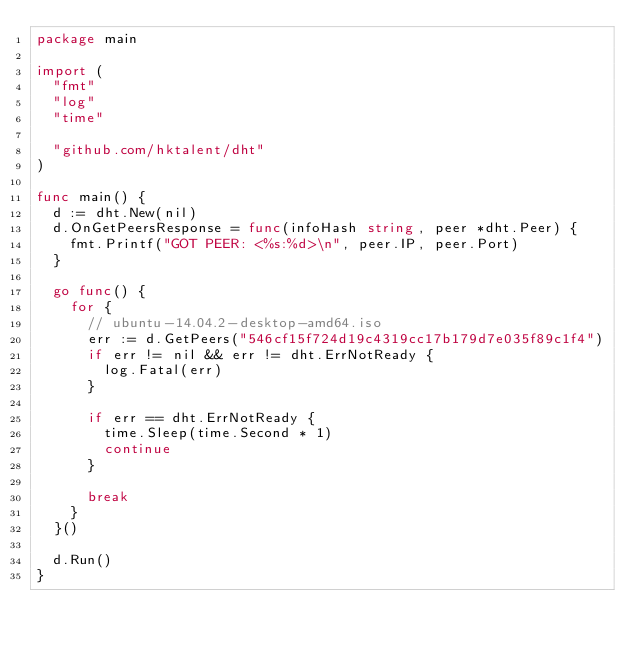<code> <loc_0><loc_0><loc_500><loc_500><_Go_>package main

import (
	"fmt"
	"log"
	"time"

	"github.com/hktalent/dht"
)

func main() {
	d := dht.New(nil)
	d.OnGetPeersResponse = func(infoHash string, peer *dht.Peer) {
		fmt.Printf("GOT PEER: <%s:%d>\n", peer.IP, peer.Port)
	}

	go func() {
		for {
			// ubuntu-14.04.2-desktop-amd64.iso
			err := d.GetPeers("546cf15f724d19c4319cc17b179d7e035f89c1f4")
			if err != nil && err != dht.ErrNotReady {
				log.Fatal(err)
			}

			if err == dht.ErrNotReady {
				time.Sleep(time.Second * 1)
				continue
			}

			break
		}
	}()

	d.Run()
}
</code> 